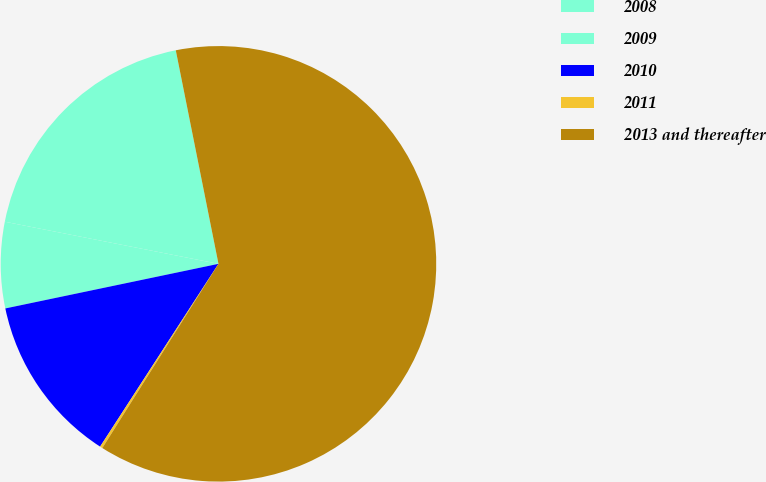<chart> <loc_0><loc_0><loc_500><loc_500><pie_chart><fcel>2008<fcel>2009<fcel>2010<fcel>2011<fcel>2013 and thereafter<nl><fcel>18.76%<fcel>6.38%<fcel>12.57%<fcel>0.19%<fcel>62.09%<nl></chart> 